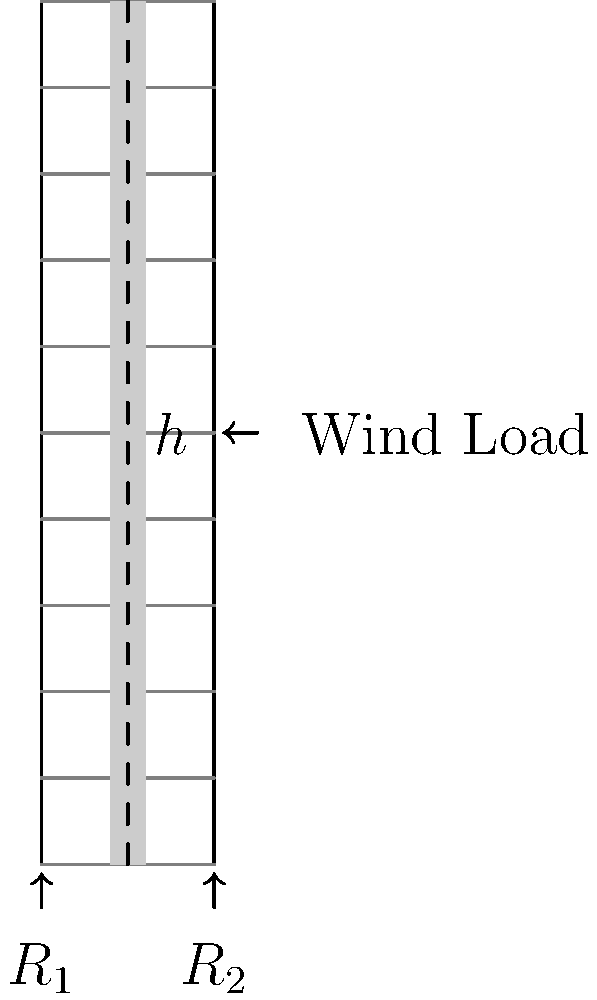As a film theorist analyzing the portrayal of urban landscapes in cinema, you encounter a scene featuring a skyscraper. The director claims the building's design is structurally sound. Given the simplified blueprint shown, with a height $h$ and width $w$, and assuming a uniform wind load $F$ acting at the building's midpoint, determine the maximum bending moment $M_{max}$ at the base. How might this structural analysis inform your critique of the film's representation of urban architecture? To analyze the structural integrity of the skyscraper and its cinematic representation, we'll follow these steps:

1. Identify the problem: We're dealing with a simplification of a cantilever beam problem, where the skyscraper is fixed at the base and subjected to a wind load.

2. Given information:
   - Height of the building: $h$
   - Width of the building: $w$
   - Wind load: $F$ (acting at the midpoint)

3. Calculate the moment arm:
   The wind load acts at the midpoint, so the moment arm is $\frac{h}{2}$.

4. Calculate the maximum bending moment:
   The maximum bending moment occurs at the base of the building.
   $M_{max} = F \times \frac{h}{2}$

5. Cinematic analysis:
   This structural analysis can inform your critique in several ways:
   a) Realism: Does the film accurately represent the building's response to environmental forces?
   b) Symbolism: Is the structural integrity of the building a metaphor for societal stability or fragility?
   c) Visual storytelling: How does the director use the building's design to convey themes or create tension?
   d) Urban representation: Does the film's portrayal of skyscrapers reflect real-world architectural trends and challenges?

6. Interdisciplinary approach:
   By understanding the structural principles, you can evaluate how well the film integrates scientific accuracy with artistic expression, potentially enriching your critique of the film's approach to urban landscapes.
Answer: $M_{max} = F \times \frac{h}{2}$; Informs critique on realism, symbolism, visual storytelling, and urban representation in film. 